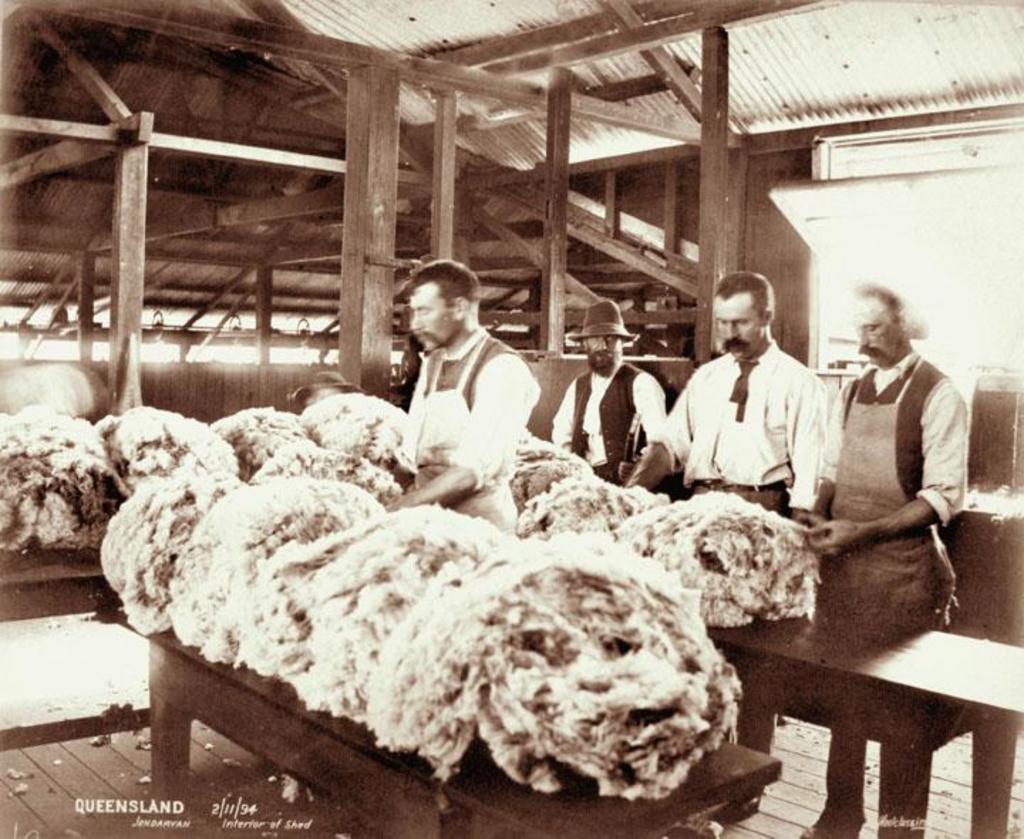Please provide a concise description of this image. This is a black and white picture, there are four persons standing on a wooden floor in front of this people there is something on the tables. Behind the people there are pole and a roof. 